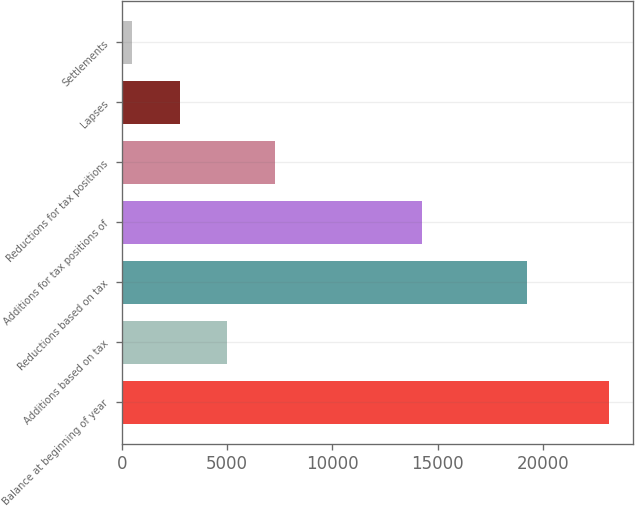Convert chart. <chart><loc_0><loc_0><loc_500><loc_500><bar_chart><fcel>Balance at beginning of year<fcel>Additions based on tax<fcel>Reductions based on tax<fcel>Additions for tax positions of<fcel>Reductions for tax positions<fcel>Lapses<fcel>Settlements<nl><fcel>23142<fcel>5024.4<fcel>19266<fcel>14277<fcel>7289.1<fcel>2759.7<fcel>495<nl></chart> 